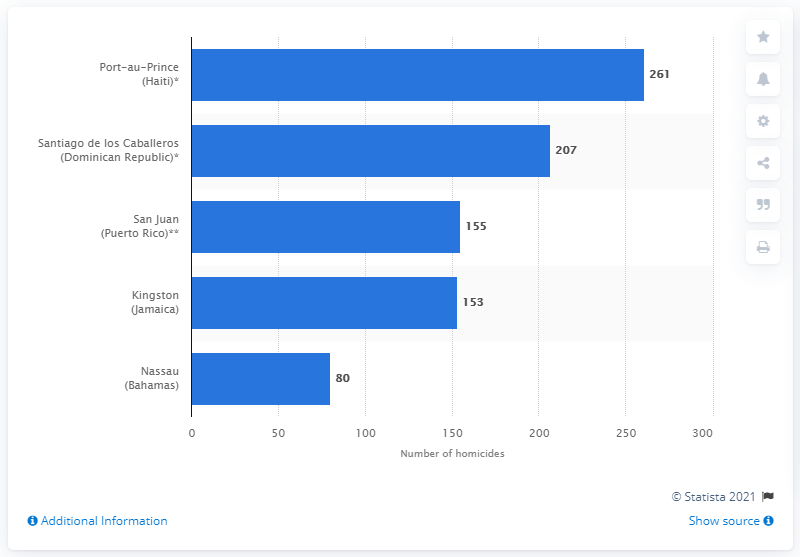Indicate a few pertinent items in this graphic. In 2015, a total of 261 homicides occurred in Haiti. In 2016, a total of 155 people were murdered in the city of San Juan, Puerto Rico. In 2018, there were 153 homicide victims in Kingston. 